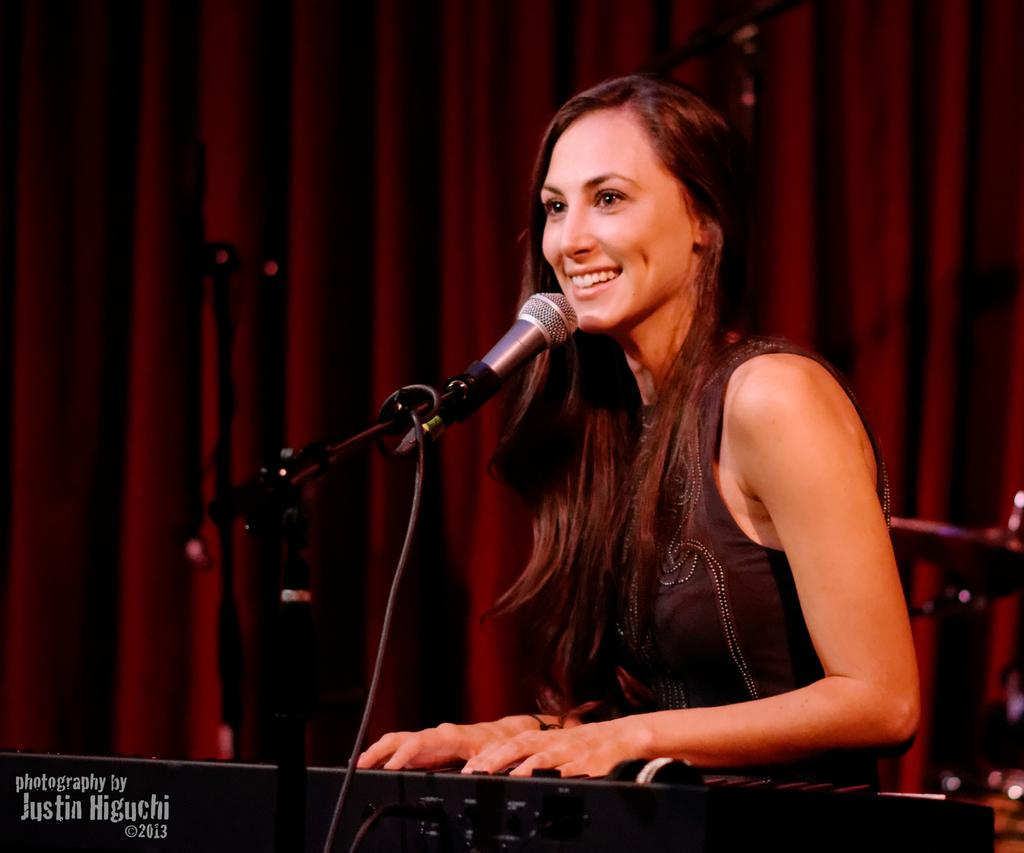Who is the main subject in the image? There is a woman in the image. What is the woman doing in the image? The woman is playing a piano. What object is placed in front of the piano? There is a microphone in front of the piano. How does the woman appear to be feeling in the image? The woman is laughing. What can be seen in the background of the image? There is a curtain in the background of the image. How does the camera capture the quiet moment in the image? There is no camera present in the image, and the woman is laughing, not experiencing a quiet moment. 